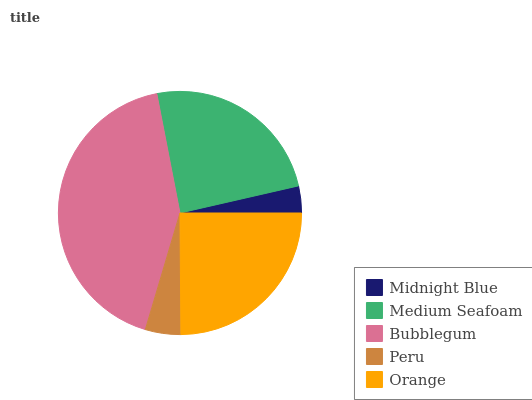Is Midnight Blue the minimum?
Answer yes or no. Yes. Is Bubblegum the maximum?
Answer yes or no. Yes. Is Medium Seafoam the minimum?
Answer yes or no. No. Is Medium Seafoam the maximum?
Answer yes or no. No. Is Medium Seafoam greater than Midnight Blue?
Answer yes or no. Yes. Is Midnight Blue less than Medium Seafoam?
Answer yes or no. Yes. Is Midnight Blue greater than Medium Seafoam?
Answer yes or no. No. Is Medium Seafoam less than Midnight Blue?
Answer yes or no. No. Is Medium Seafoam the high median?
Answer yes or no. Yes. Is Medium Seafoam the low median?
Answer yes or no. Yes. Is Bubblegum the high median?
Answer yes or no. No. Is Midnight Blue the low median?
Answer yes or no. No. 